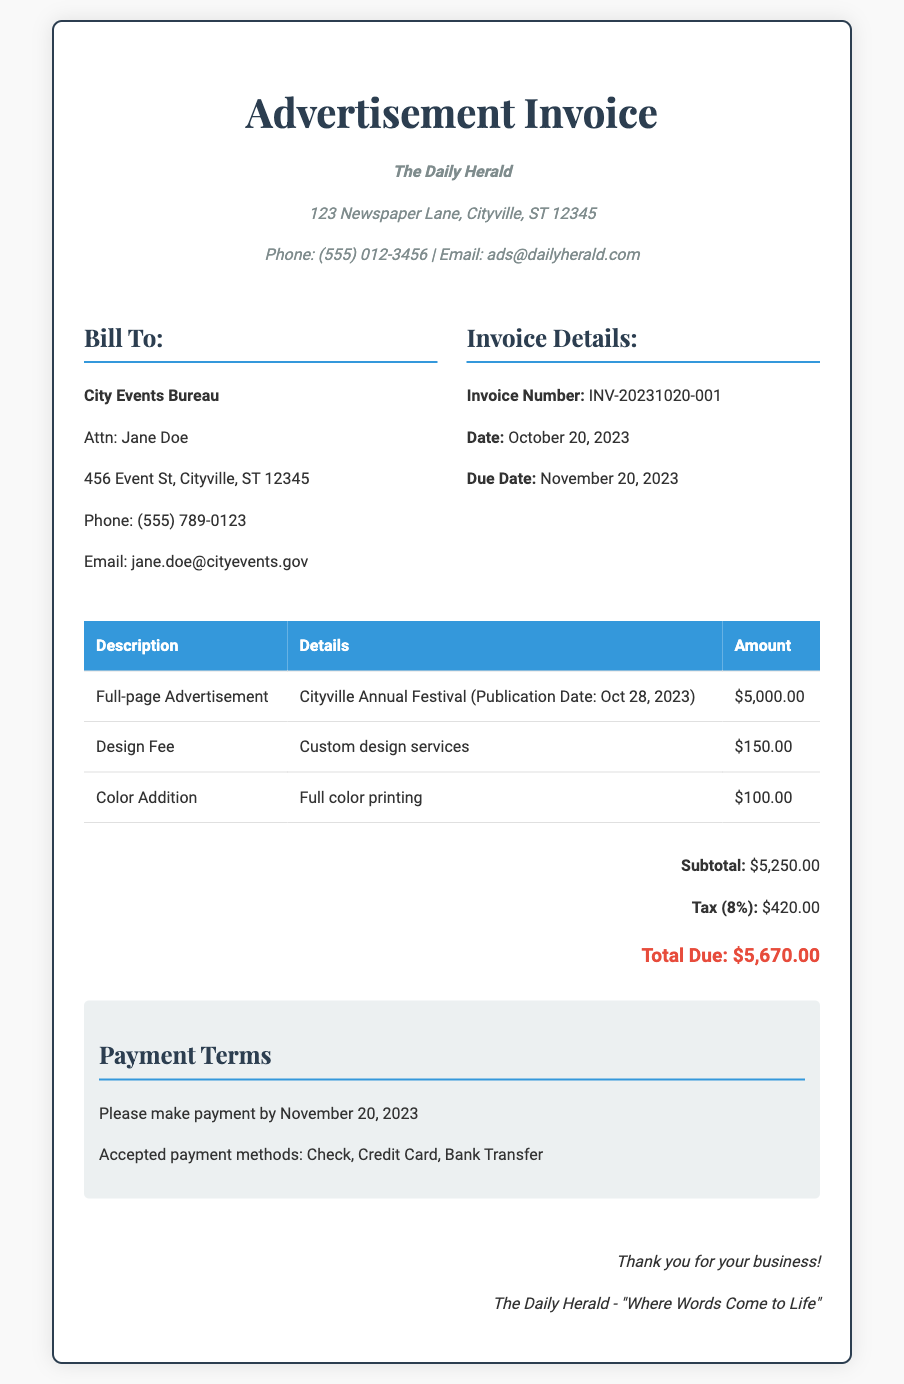What is the total cost of the full-page advertisement? The total cost is the only amount listed for the full-page advertisement in the invoice, which is $5,000.00.
Answer: $5,000.00 What is the due date for payment? The due date is specified in the "Invoice Details" section as November 20, 2023.
Answer: November 20, 2023 Who is the contact person for the billing? The contact person for the billing is mentioned as Jane Doe in the "Bill To" section.
Answer: Jane Doe What is the tax percentage applied? The tax percentage is indicated in the "Totals" section, which is 8%.
Answer: 8% What is the subtotal amount? The subtotal is provided in the "Totals" section as $5,250.00.
Answer: $5,250.00 What is the total due amount? The total due amount is clearly stated in the "Totals" section as $5,670.00.
Answer: $5,670.00 What services are included in the invoice? The services included are a full-page advertisement, design fee, and color addition.
Answer: Full-page advertisement, design fee, color addition What is the payment term for this invoice? The payment term is specified as making payment by November 20, 2023.
Answer: By November 20, 2023 What company is issuing the invoice? The company issuing the invoice is mentioned at the top as The Daily Herald.
Answer: The Daily Herald 